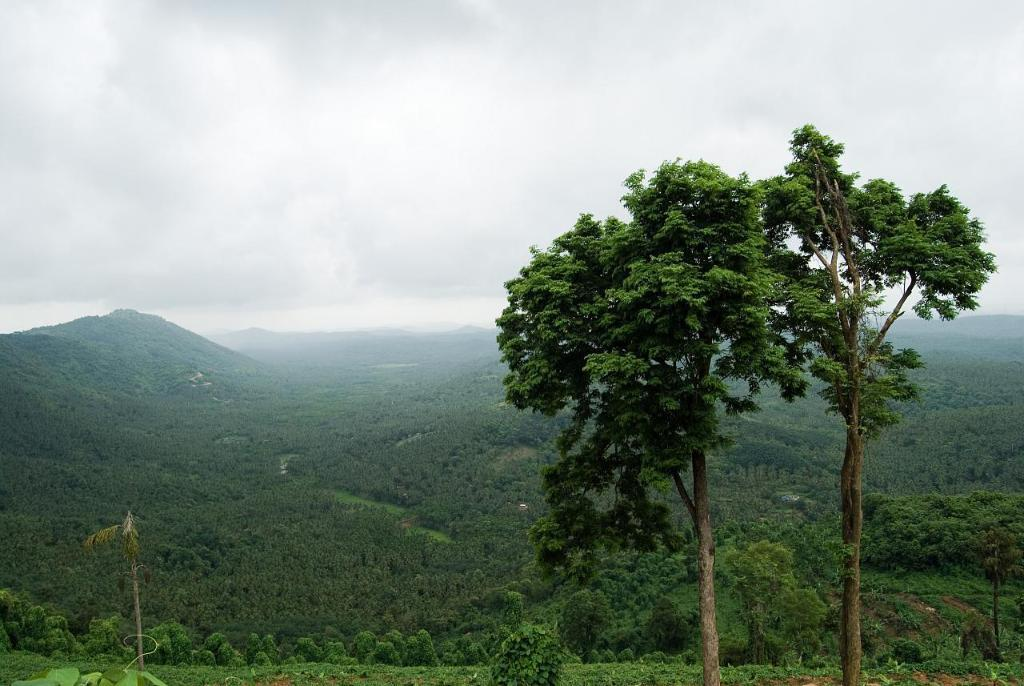What type of vegetation can be seen in the image? There are trees in the image. What structures are present in the image? There are poles in the image. What type of landscape feature is visible in the image? There are hills in the image. What is visible at the top of the image? The sky is visible at the top of the image. What type of knowledge can be gained from the trees in the image? The trees in the image do not convey any knowledge; they are simply a part of the landscape. How does the knee of the hill in the image affect the overall composition? There is no mention of a knee in the image, and hills do not have knees. 